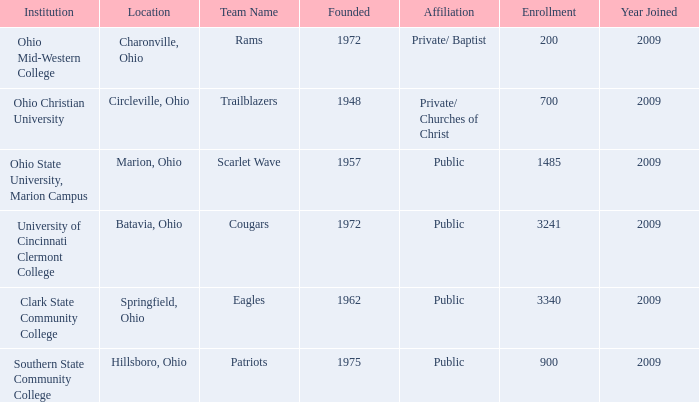What is the affiliation when the institution was ohio christian university? Private/ Churches of Christ. 